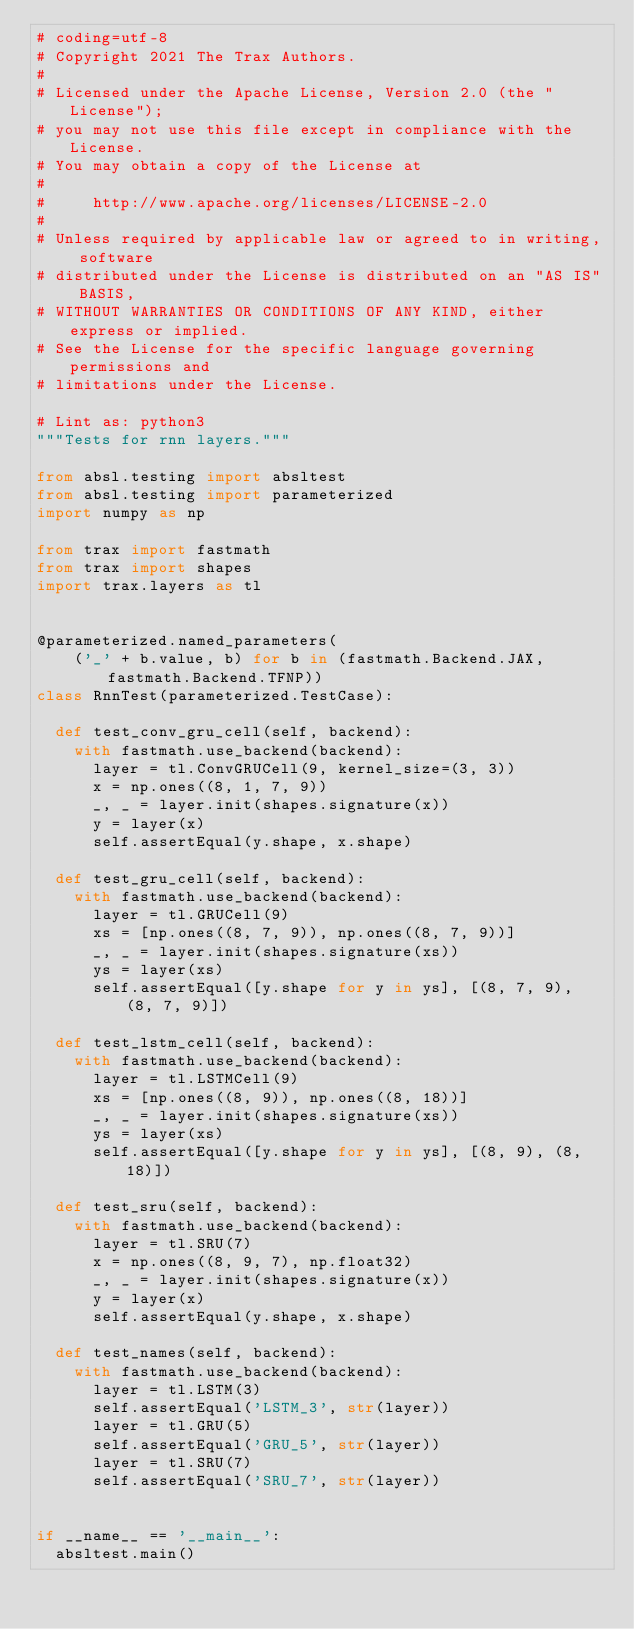Convert code to text. <code><loc_0><loc_0><loc_500><loc_500><_Python_># coding=utf-8
# Copyright 2021 The Trax Authors.
#
# Licensed under the Apache License, Version 2.0 (the "License");
# you may not use this file except in compliance with the License.
# You may obtain a copy of the License at
#
#     http://www.apache.org/licenses/LICENSE-2.0
#
# Unless required by applicable law or agreed to in writing, software
# distributed under the License is distributed on an "AS IS" BASIS,
# WITHOUT WARRANTIES OR CONDITIONS OF ANY KIND, either express or implied.
# See the License for the specific language governing permissions and
# limitations under the License.

# Lint as: python3
"""Tests for rnn layers."""

from absl.testing import absltest
from absl.testing import parameterized
import numpy as np

from trax import fastmath
from trax import shapes
import trax.layers as tl


@parameterized.named_parameters(
    ('_' + b.value, b) for b in (fastmath.Backend.JAX, fastmath.Backend.TFNP))
class RnnTest(parameterized.TestCase):

  def test_conv_gru_cell(self, backend):
    with fastmath.use_backend(backend):
      layer = tl.ConvGRUCell(9, kernel_size=(3, 3))
      x = np.ones((8, 1, 7, 9))
      _, _ = layer.init(shapes.signature(x))
      y = layer(x)
      self.assertEqual(y.shape, x.shape)

  def test_gru_cell(self, backend):
    with fastmath.use_backend(backend):
      layer = tl.GRUCell(9)
      xs = [np.ones((8, 7, 9)), np.ones((8, 7, 9))]
      _, _ = layer.init(shapes.signature(xs))
      ys = layer(xs)
      self.assertEqual([y.shape for y in ys], [(8, 7, 9), (8, 7, 9)])

  def test_lstm_cell(self, backend):
    with fastmath.use_backend(backend):
      layer = tl.LSTMCell(9)
      xs = [np.ones((8, 9)), np.ones((8, 18))]
      _, _ = layer.init(shapes.signature(xs))
      ys = layer(xs)
      self.assertEqual([y.shape for y in ys], [(8, 9), (8, 18)])

  def test_sru(self, backend):
    with fastmath.use_backend(backend):
      layer = tl.SRU(7)
      x = np.ones((8, 9, 7), np.float32)
      _, _ = layer.init(shapes.signature(x))
      y = layer(x)
      self.assertEqual(y.shape, x.shape)

  def test_names(self, backend):
    with fastmath.use_backend(backend):
      layer = tl.LSTM(3)
      self.assertEqual('LSTM_3', str(layer))
      layer = tl.GRU(5)
      self.assertEqual('GRU_5', str(layer))
      layer = tl.SRU(7)
      self.assertEqual('SRU_7', str(layer))


if __name__ == '__main__':
  absltest.main()
</code> 